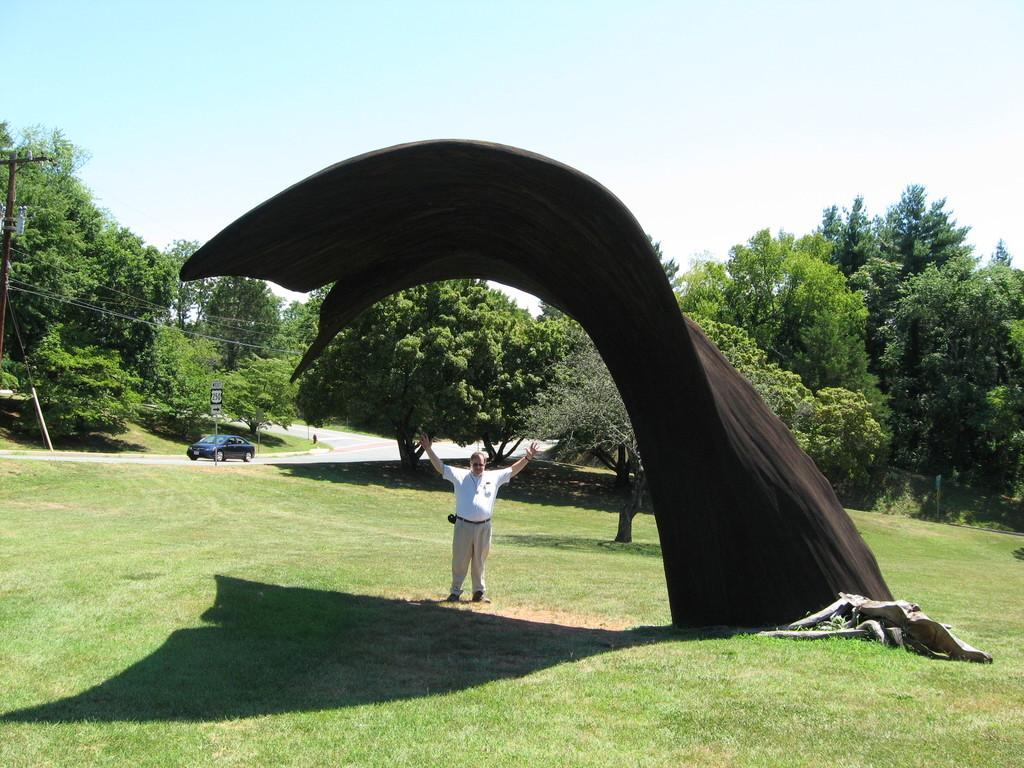What type of vegetation can be seen in the image? There is grass present in the image. What is the man in the image doing? The man is standing in the image. What color is the cloth in the image? The cloth in the image is black. What else can be seen in the image besides the grass and man? Trees, a blue color car, and a sign pole are visible in the image. What is visible at the top of the image? The sky is visible at the top of the image. What type of can is being used by the man in the image? There is no can present in the image; the man is simply standing. What arithmetic problem is being solved by the trees in the image? The trees are not solving any arithmetic problems; they are simply trees. 